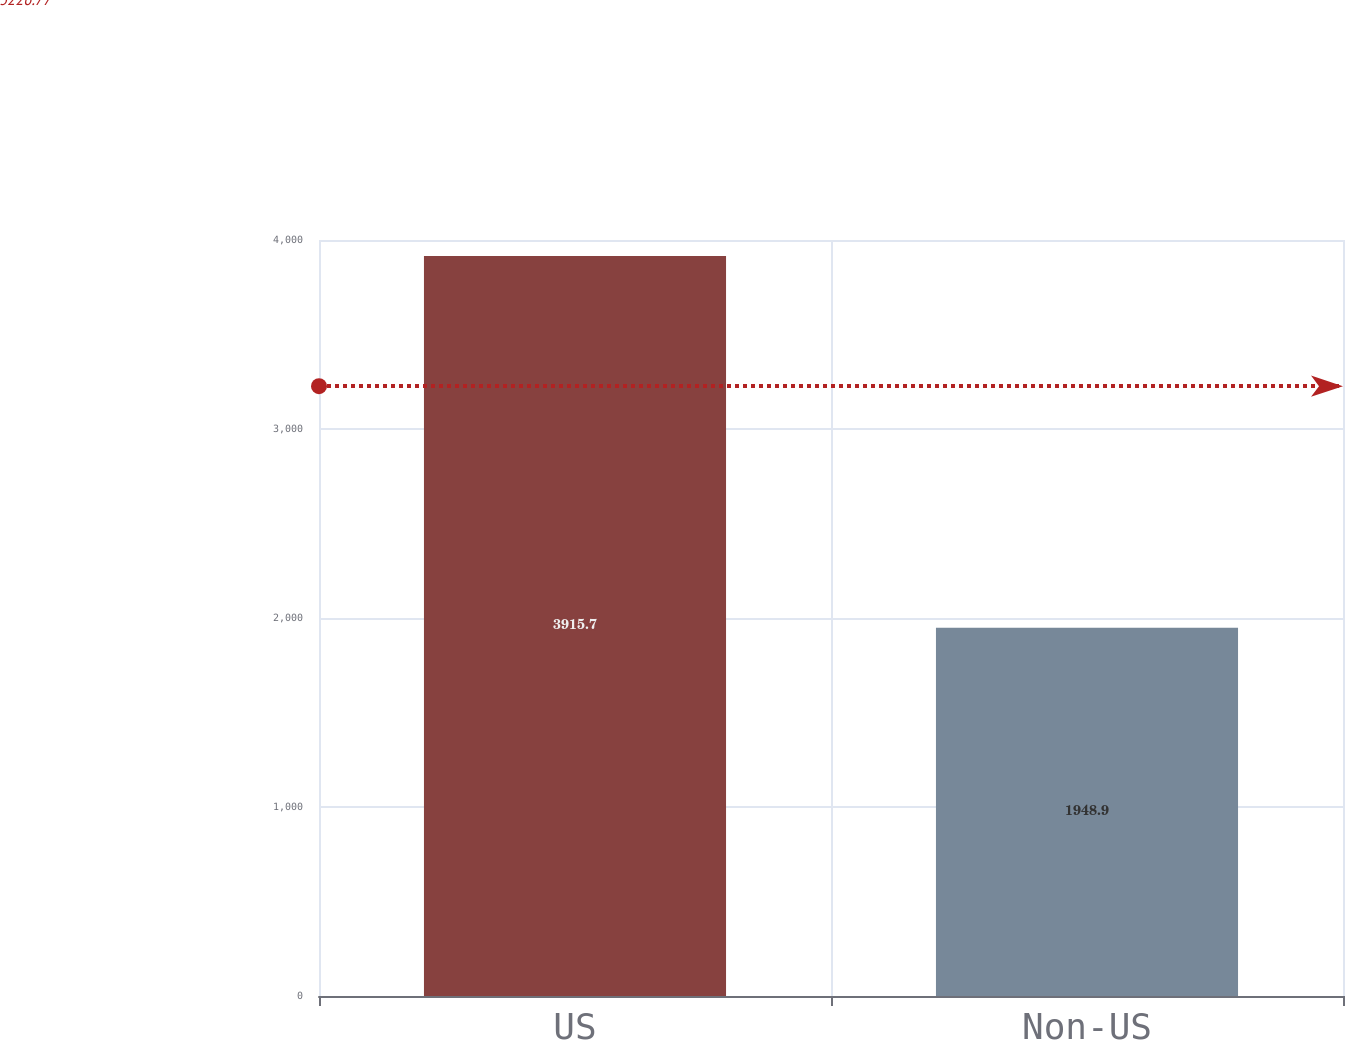<chart> <loc_0><loc_0><loc_500><loc_500><bar_chart><fcel>US<fcel>Non-US<nl><fcel>3915.7<fcel>1948.9<nl></chart> 